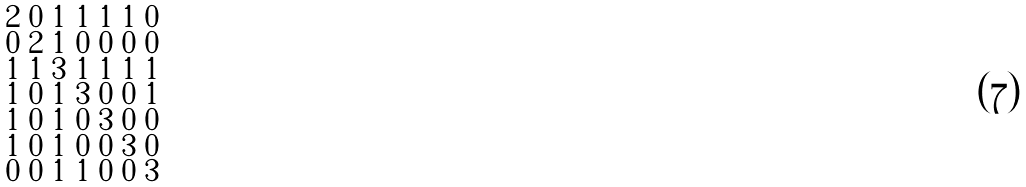Convert formula to latex. <formula><loc_0><loc_0><loc_500><loc_500>\begin{smallmatrix} 2 & 0 & 1 & 1 & 1 & 1 & 0 \\ 0 & 2 & 1 & 0 & 0 & 0 & 0 \\ 1 & 1 & 3 & 1 & 1 & 1 & 1 \\ 1 & 0 & 1 & 3 & 0 & 0 & 1 \\ 1 & 0 & 1 & 0 & 3 & 0 & 0 \\ 1 & 0 & 1 & 0 & 0 & 3 & 0 \\ 0 & 0 & 1 & 1 & 0 & 0 & 3 \end{smallmatrix}</formula> 